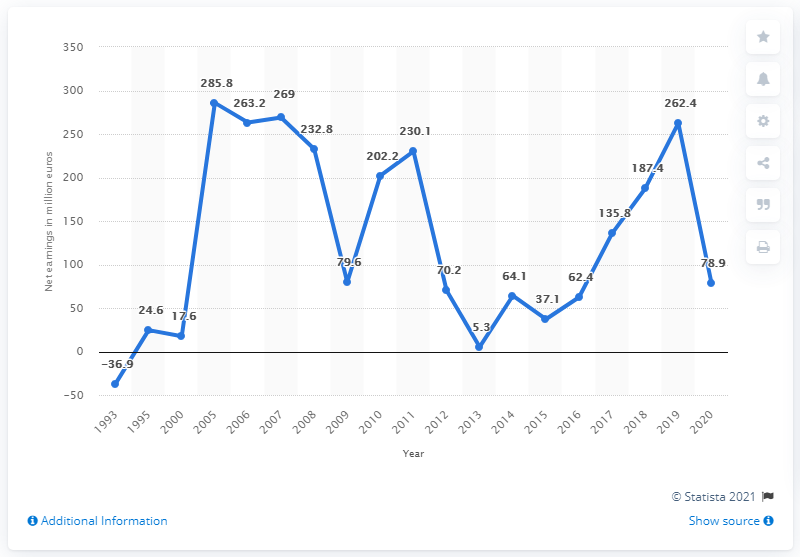List a handful of essential elements in this visual. Puma's net earnings in 2020 were 78.9 million. 